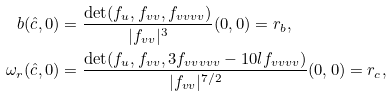<formula> <loc_0><loc_0><loc_500><loc_500>b ( \hat { c } , 0 ) & = \frac { \det ( f _ { u } , f _ { v v } , f _ { v v v v } ) } { | f _ { v v } | ^ { 3 } } ( 0 , 0 ) = r _ { b } , \\ \omega _ { r } ( \hat { c } , 0 ) & = \frac { \det ( f _ { u } , f _ { v v } , 3 f _ { v v v v v } - 1 0 l f _ { v v v v } ) } { | f _ { v v } | ^ { 7 / 2 } } ( 0 , 0 ) = r _ { c } ,</formula> 